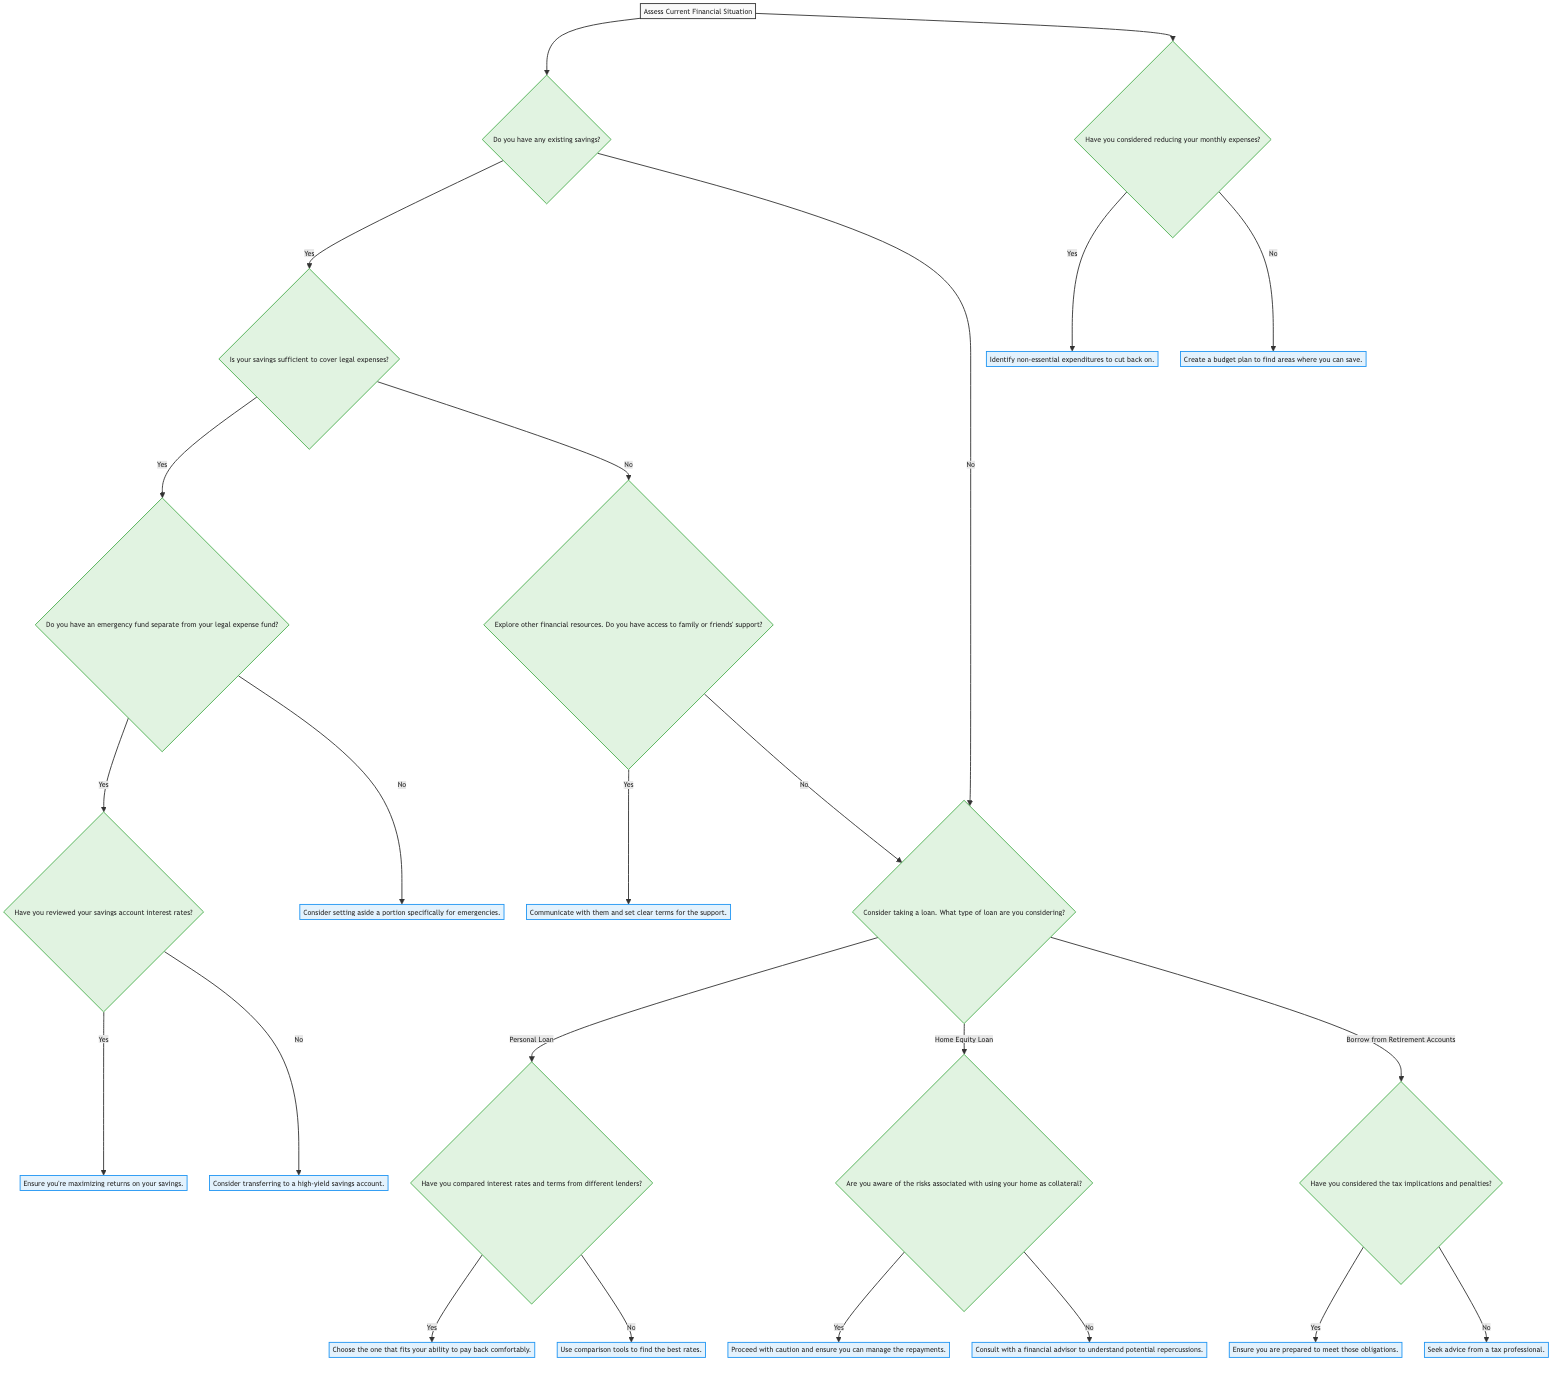What is the starting point of the decision tree? The starting point of the decision tree is identified as "Assess Current Financial Situation" which acts as the primary phase for evaluating financial management during legal battles.
Answer: Assess Current Financial Situation How many nodes are there in the diagram? To find the total number of nodes, we count each decision point or outcome represented in the decision tree. There are 10 nodes in total as shown in the decision process.
Answer: 10 What is the first question to consider regarding existing savings? The first question regarding existing savings is "Do you have any existing savings?" which guides the journey through the financial options available.
Answer: Do you have any existing savings? If savings are insufficient, what is the next step? If savings are insufficient to cover legal expenses, the next step is to explore other financial resources and assess if there is access to family or friends' support, which is key for additional assistance.
Answer: Explore other financial resources What happens if you have a personal loan option? If you are considering a personal loan, the next question is about whether you have compared interest rates and terms from different lenders. This is crucial for making an informed decision on which loan to choose.
Answer: Have you compared interest rates and terms from different lenders? What should you do if you haven’t reviewed savings interest rates? If you haven’t reviewed your savings account interest rates, you should consider transferring to a high-yield savings account to maximize returns on your savings, which is important during legal battles.
Answer: Consider transferring to a high-yield savings account What is the risk associated with a home equity loan? If considering a home equity loan, it is important to be aware of the risks associated with using your home as collateral, ensuring you can manage the repayments is essential to avoid losing your home.
Answer: Risks associated with using your home as collateral What should you do if you haven’t thought about reducing monthly expenses? If you haven’t considered reducing monthly expenses, it is advised to create a budget plan to find areas where you can save money which could help alleviate financial pressure during the legal process.
Answer: Create a budget plan to find areas where you can save What should you consider if you are borrowing from retirement accounts? If borrowing from retirement accounts, you should consider the tax implications and penalties that come with it, ensuring you are prepared to meet those obligations to avoid future financial issues.
Answer: Tax implications and penalties 